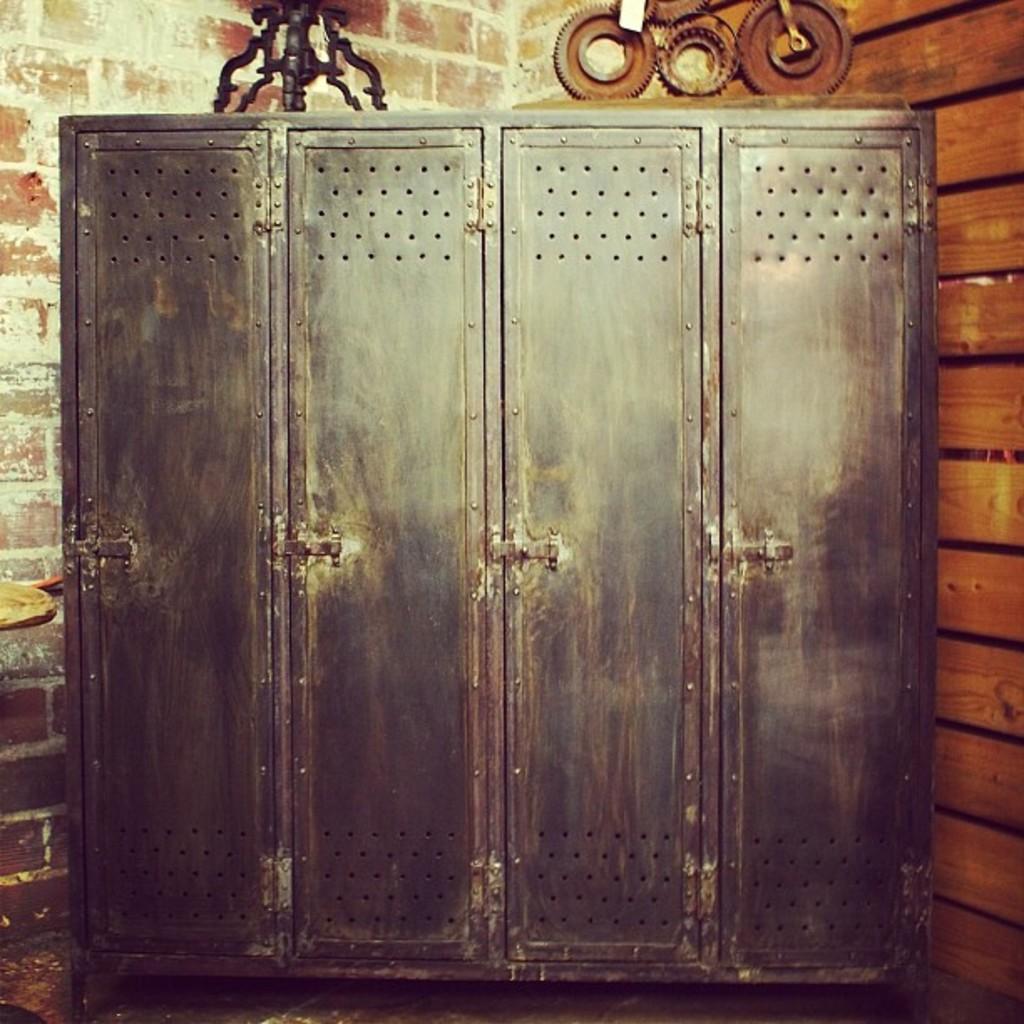Can you describe this image briefly? The image is looking like a cabinet. On the left it is brick wall. On the right we can see wooden object. At the top there are some iron objects. 